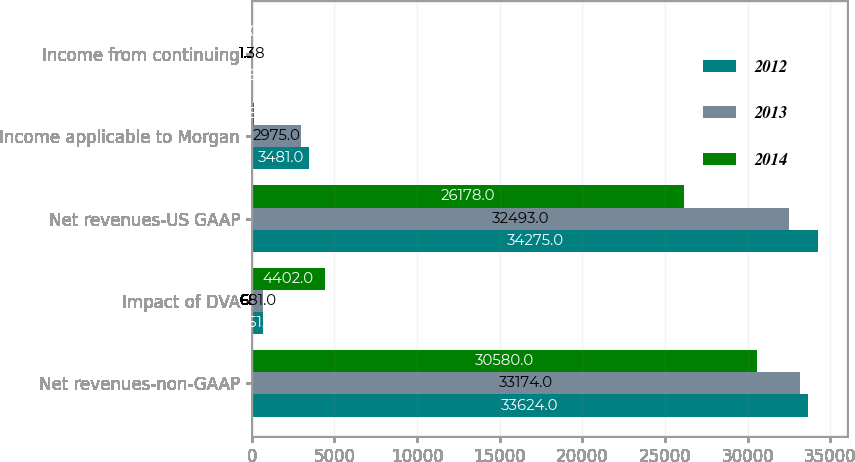Convert chart. <chart><loc_0><loc_0><loc_500><loc_500><stacked_bar_chart><ecel><fcel>Net revenues-non-GAAP<fcel>Impact of DVA<fcel>Net revenues-US GAAP<fcel>Income applicable to Morgan<fcel>Income from continuing<nl><fcel>2012<fcel>33624<fcel>651<fcel>34275<fcel>3481<fcel>1.61<nl><fcel>2013<fcel>33174<fcel>681<fcel>32493<fcel>2975<fcel>1.38<nl><fcel>2014<fcel>30580<fcel>4402<fcel>26178<fcel>138<fcel>0.02<nl></chart> 